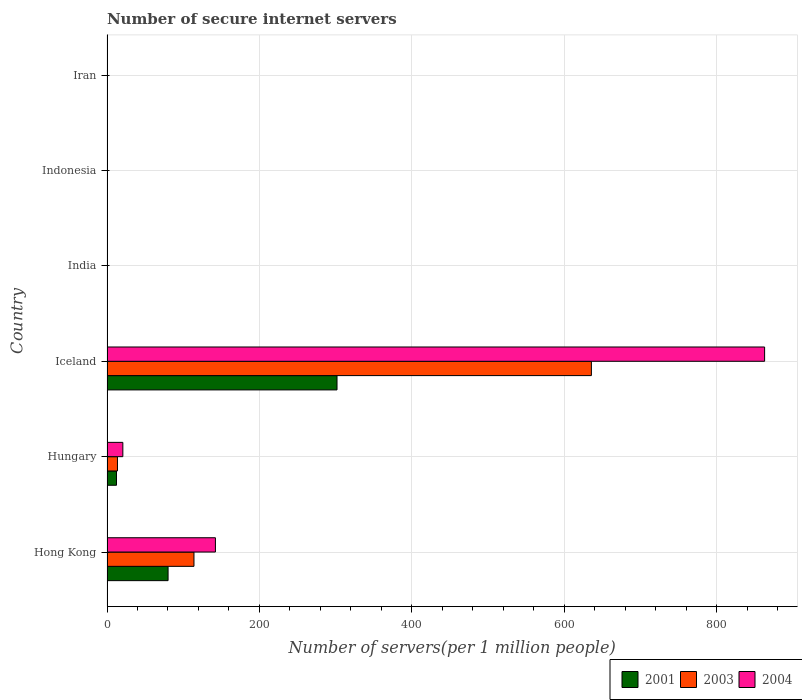Are the number of bars per tick equal to the number of legend labels?
Provide a short and direct response. Yes. How many bars are there on the 4th tick from the bottom?
Give a very brief answer. 3. What is the label of the 6th group of bars from the top?
Your response must be concise. Hong Kong. In how many cases, is the number of bars for a given country not equal to the number of legend labels?
Ensure brevity in your answer.  0. What is the number of secure internet servers in 2001 in Hungary?
Ensure brevity in your answer.  12.47. Across all countries, what is the maximum number of secure internet servers in 2001?
Your response must be concise. 301.79. Across all countries, what is the minimum number of secure internet servers in 2004?
Your answer should be compact. 0.19. In which country was the number of secure internet servers in 2003 minimum?
Your answer should be compact. Iran. What is the total number of secure internet servers in 2004 in the graph?
Your response must be concise. 1026.81. What is the difference between the number of secure internet servers in 2001 in Hungary and that in Iceland?
Your answer should be compact. -289.32. What is the difference between the number of secure internet servers in 2004 in Hong Kong and the number of secure internet servers in 2001 in Indonesia?
Your answer should be very brief. 141.98. What is the average number of secure internet servers in 2003 per country?
Your response must be concise. 127.32. What is the difference between the number of secure internet servers in 2003 and number of secure internet servers in 2001 in India?
Your answer should be very brief. 0.14. What is the ratio of the number of secure internet servers in 2004 in Hong Kong to that in India?
Make the answer very short. 346.84. Is the number of secure internet servers in 2001 in Hong Kong less than that in Hungary?
Make the answer very short. No. What is the difference between the highest and the second highest number of secure internet servers in 2003?
Ensure brevity in your answer.  521.43. What is the difference between the highest and the lowest number of secure internet servers in 2004?
Provide a short and direct response. 862.61. In how many countries, is the number of secure internet servers in 2003 greater than the average number of secure internet servers in 2003 taken over all countries?
Provide a short and direct response. 1. What does the 3rd bar from the top in Indonesia represents?
Make the answer very short. 2001. What does the 2nd bar from the bottom in Hungary represents?
Offer a very short reply. 2003. How many countries are there in the graph?
Your response must be concise. 6. Are the values on the major ticks of X-axis written in scientific E-notation?
Keep it short and to the point. No. Does the graph contain grids?
Keep it short and to the point. Yes. Where does the legend appear in the graph?
Your response must be concise. Bottom right. How many legend labels are there?
Give a very brief answer. 3. How are the legend labels stacked?
Make the answer very short. Horizontal. What is the title of the graph?
Your answer should be very brief. Number of secure internet servers. Does "1984" appear as one of the legend labels in the graph?
Your answer should be very brief. No. What is the label or title of the X-axis?
Give a very brief answer. Number of servers(per 1 million people). What is the Number of servers(per 1 million people) of 2001 in Hong Kong?
Your answer should be very brief. 80.13. What is the Number of servers(per 1 million people) of 2003 in Hong Kong?
Offer a terse response. 114.1. What is the Number of servers(per 1 million people) of 2004 in Hong Kong?
Offer a terse response. 142.26. What is the Number of servers(per 1 million people) of 2001 in Hungary?
Ensure brevity in your answer.  12.47. What is the Number of servers(per 1 million people) in 2003 in Hungary?
Ensure brevity in your answer.  13.72. What is the Number of servers(per 1 million people) of 2004 in Hungary?
Provide a succinct answer. 20.78. What is the Number of servers(per 1 million people) of 2001 in Iceland?
Your response must be concise. 301.79. What is the Number of servers(per 1 million people) in 2003 in Iceland?
Keep it short and to the point. 635.53. What is the Number of servers(per 1 million people) of 2004 in Iceland?
Your response must be concise. 862.8. What is the Number of servers(per 1 million people) of 2001 in India?
Keep it short and to the point. 0.11. What is the Number of servers(per 1 million people) in 2003 in India?
Your answer should be compact. 0.25. What is the Number of servers(per 1 million people) in 2004 in India?
Keep it short and to the point. 0.41. What is the Number of servers(per 1 million people) of 2001 in Indonesia?
Provide a short and direct response. 0.28. What is the Number of servers(per 1 million people) in 2003 in Indonesia?
Make the answer very short. 0.27. What is the Number of servers(per 1 million people) in 2004 in Indonesia?
Your response must be concise. 0.38. What is the Number of servers(per 1 million people) in 2001 in Iran?
Your response must be concise. 0.01. What is the Number of servers(per 1 million people) of 2003 in Iran?
Keep it short and to the point. 0.01. What is the Number of servers(per 1 million people) in 2004 in Iran?
Give a very brief answer. 0.19. Across all countries, what is the maximum Number of servers(per 1 million people) in 2001?
Keep it short and to the point. 301.79. Across all countries, what is the maximum Number of servers(per 1 million people) of 2003?
Your answer should be very brief. 635.53. Across all countries, what is the maximum Number of servers(per 1 million people) in 2004?
Provide a short and direct response. 862.8. Across all countries, what is the minimum Number of servers(per 1 million people) of 2001?
Keep it short and to the point. 0.01. Across all countries, what is the minimum Number of servers(per 1 million people) in 2003?
Make the answer very short. 0.01. Across all countries, what is the minimum Number of servers(per 1 million people) in 2004?
Give a very brief answer. 0.19. What is the total Number of servers(per 1 million people) in 2001 in the graph?
Offer a terse response. 394.79. What is the total Number of servers(per 1 million people) in 2003 in the graph?
Keep it short and to the point. 763.9. What is the total Number of servers(per 1 million people) of 2004 in the graph?
Your answer should be very brief. 1026.81. What is the difference between the Number of servers(per 1 million people) of 2001 in Hong Kong and that in Hungary?
Your answer should be very brief. 67.66. What is the difference between the Number of servers(per 1 million people) in 2003 in Hong Kong and that in Hungary?
Give a very brief answer. 100.38. What is the difference between the Number of servers(per 1 million people) of 2004 in Hong Kong and that in Hungary?
Keep it short and to the point. 121.48. What is the difference between the Number of servers(per 1 million people) in 2001 in Hong Kong and that in Iceland?
Give a very brief answer. -221.66. What is the difference between the Number of servers(per 1 million people) in 2003 in Hong Kong and that in Iceland?
Keep it short and to the point. -521.43. What is the difference between the Number of servers(per 1 million people) of 2004 in Hong Kong and that in Iceland?
Keep it short and to the point. -720.54. What is the difference between the Number of servers(per 1 million people) of 2001 in Hong Kong and that in India?
Make the answer very short. 80.01. What is the difference between the Number of servers(per 1 million people) of 2003 in Hong Kong and that in India?
Provide a short and direct response. 113.85. What is the difference between the Number of servers(per 1 million people) of 2004 in Hong Kong and that in India?
Provide a succinct answer. 141.85. What is the difference between the Number of servers(per 1 million people) in 2001 in Hong Kong and that in Indonesia?
Your answer should be compact. 79.85. What is the difference between the Number of servers(per 1 million people) in 2003 in Hong Kong and that in Indonesia?
Make the answer very short. 113.83. What is the difference between the Number of servers(per 1 million people) of 2004 in Hong Kong and that in Indonesia?
Your answer should be very brief. 141.88. What is the difference between the Number of servers(per 1 million people) of 2001 in Hong Kong and that in Iran?
Provide a short and direct response. 80.11. What is the difference between the Number of servers(per 1 million people) of 2003 in Hong Kong and that in Iran?
Provide a succinct answer. 114.09. What is the difference between the Number of servers(per 1 million people) of 2004 in Hong Kong and that in Iran?
Offer a terse response. 142.07. What is the difference between the Number of servers(per 1 million people) of 2001 in Hungary and that in Iceland?
Provide a short and direct response. -289.32. What is the difference between the Number of servers(per 1 million people) of 2003 in Hungary and that in Iceland?
Make the answer very short. -621.81. What is the difference between the Number of servers(per 1 million people) in 2004 in Hungary and that in Iceland?
Your answer should be very brief. -842.02. What is the difference between the Number of servers(per 1 million people) of 2001 in Hungary and that in India?
Provide a short and direct response. 12.35. What is the difference between the Number of servers(per 1 million people) in 2003 in Hungary and that in India?
Keep it short and to the point. 13.47. What is the difference between the Number of servers(per 1 million people) in 2004 in Hungary and that in India?
Give a very brief answer. 20.37. What is the difference between the Number of servers(per 1 million people) in 2001 in Hungary and that in Indonesia?
Your answer should be compact. 12.19. What is the difference between the Number of servers(per 1 million people) in 2003 in Hungary and that in Indonesia?
Offer a very short reply. 13.45. What is the difference between the Number of servers(per 1 million people) of 2004 in Hungary and that in Indonesia?
Offer a very short reply. 20.4. What is the difference between the Number of servers(per 1 million people) of 2001 in Hungary and that in Iran?
Make the answer very short. 12.45. What is the difference between the Number of servers(per 1 million people) in 2003 in Hungary and that in Iran?
Give a very brief answer. 13.71. What is the difference between the Number of servers(per 1 million people) in 2004 in Hungary and that in Iran?
Provide a succinct answer. 20.59. What is the difference between the Number of servers(per 1 million people) in 2001 in Iceland and that in India?
Provide a succinct answer. 301.67. What is the difference between the Number of servers(per 1 million people) in 2003 in Iceland and that in India?
Provide a succinct answer. 635.28. What is the difference between the Number of servers(per 1 million people) of 2004 in Iceland and that in India?
Ensure brevity in your answer.  862.38. What is the difference between the Number of servers(per 1 million people) of 2001 in Iceland and that in Indonesia?
Offer a very short reply. 301.51. What is the difference between the Number of servers(per 1 million people) in 2003 in Iceland and that in Indonesia?
Give a very brief answer. 635.26. What is the difference between the Number of servers(per 1 million people) in 2004 in Iceland and that in Indonesia?
Your response must be concise. 862.41. What is the difference between the Number of servers(per 1 million people) of 2001 in Iceland and that in Iran?
Your answer should be very brief. 301.77. What is the difference between the Number of servers(per 1 million people) in 2003 in Iceland and that in Iran?
Offer a terse response. 635.52. What is the difference between the Number of servers(per 1 million people) in 2004 in Iceland and that in Iran?
Your answer should be very brief. 862.61. What is the difference between the Number of servers(per 1 million people) in 2001 in India and that in Indonesia?
Ensure brevity in your answer.  -0.17. What is the difference between the Number of servers(per 1 million people) of 2003 in India and that in Indonesia?
Give a very brief answer. -0.02. What is the difference between the Number of servers(per 1 million people) in 2004 in India and that in Indonesia?
Offer a very short reply. 0.03. What is the difference between the Number of servers(per 1 million people) of 2001 in India and that in Iran?
Keep it short and to the point. 0.1. What is the difference between the Number of servers(per 1 million people) of 2003 in India and that in Iran?
Make the answer very short. 0.24. What is the difference between the Number of servers(per 1 million people) in 2004 in India and that in Iran?
Offer a very short reply. 0.22. What is the difference between the Number of servers(per 1 million people) of 2001 in Indonesia and that in Iran?
Keep it short and to the point. 0.26. What is the difference between the Number of servers(per 1 million people) of 2003 in Indonesia and that in Iran?
Your answer should be very brief. 0.26. What is the difference between the Number of servers(per 1 million people) in 2004 in Indonesia and that in Iran?
Ensure brevity in your answer.  0.19. What is the difference between the Number of servers(per 1 million people) in 2001 in Hong Kong and the Number of servers(per 1 million people) in 2003 in Hungary?
Offer a terse response. 66.41. What is the difference between the Number of servers(per 1 million people) in 2001 in Hong Kong and the Number of servers(per 1 million people) in 2004 in Hungary?
Give a very brief answer. 59.35. What is the difference between the Number of servers(per 1 million people) of 2003 in Hong Kong and the Number of servers(per 1 million people) of 2004 in Hungary?
Provide a short and direct response. 93.33. What is the difference between the Number of servers(per 1 million people) in 2001 in Hong Kong and the Number of servers(per 1 million people) in 2003 in Iceland?
Make the answer very short. -555.4. What is the difference between the Number of servers(per 1 million people) in 2001 in Hong Kong and the Number of servers(per 1 million people) in 2004 in Iceland?
Provide a short and direct response. -782.67. What is the difference between the Number of servers(per 1 million people) of 2003 in Hong Kong and the Number of servers(per 1 million people) of 2004 in Iceland?
Provide a succinct answer. -748.69. What is the difference between the Number of servers(per 1 million people) of 2001 in Hong Kong and the Number of servers(per 1 million people) of 2003 in India?
Offer a very short reply. 79.87. What is the difference between the Number of servers(per 1 million people) of 2001 in Hong Kong and the Number of servers(per 1 million people) of 2004 in India?
Provide a short and direct response. 79.72. What is the difference between the Number of servers(per 1 million people) of 2003 in Hong Kong and the Number of servers(per 1 million people) of 2004 in India?
Offer a terse response. 113.69. What is the difference between the Number of servers(per 1 million people) in 2001 in Hong Kong and the Number of servers(per 1 million people) in 2003 in Indonesia?
Offer a terse response. 79.86. What is the difference between the Number of servers(per 1 million people) in 2001 in Hong Kong and the Number of servers(per 1 million people) in 2004 in Indonesia?
Give a very brief answer. 79.75. What is the difference between the Number of servers(per 1 million people) of 2003 in Hong Kong and the Number of servers(per 1 million people) of 2004 in Indonesia?
Offer a terse response. 113.72. What is the difference between the Number of servers(per 1 million people) in 2001 in Hong Kong and the Number of servers(per 1 million people) in 2003 in Iran?
Your answer should be very brief. 80.11. What is the difference between the Number of servers(per 1 million people) of 2001 in Hong Kong and the Number of servers(per 1 million people) of 2004 in Iran?
Offer a terse response. 79.94. What is the difference between the Number of servers(per 1 million people) of 2003 in Hong Kong and the Number of servers(per 1 million people) of 2004 in Iran?
Offer a very short reply. 113.91. What is the difference between the Number of servers(per 1 million people) in 2001 in Hungary and the Number of servers(per 1 million people) in 2003 in Iceland?
Your response must be concise. -623.07. What is the difference between the Number of servers(per 1 million people) in 2001 in Hungary and the Number of servers(per 1 million people) in 2004 in Iceland?
Your answer should be very brief. -850.33. What is the difference between the Number of servers(per 1 million people) in 2003 in Hungary and the Number of servers(per 1 million people) in 2004 in Iceland?
Your answer should be very brief. -849.07. What is the difference between the Number of servers(per 1 million people) in 2001 in Hungary and the Number of servers(per 1 million people) in 2003 in India?
Your answer should be compact. 12.21. What is the difference between the Number of servers(per 1 million people) in 2001 in Hungary and the Number of servers(per 1 million people) in 2004 in India?
Ensure brevity in your answer.  12.06. What is the difference between the Number of servers(per 1 million people) of 2003 in Hungary and the Number of servers(per 1 million people) of 2004 in India?
Your answer should be compact. 13.31. What is the difference between the Number of servers(per 1 million people) of 2001 in Hungary and the Number of servers(per 1 million people) of 2003 in Indonesia?
Ensure brevity in your answer.  12.19. What is the difference between the Number of servers(per 1 million people) in 2001 in Hungary and the Number of servers(per 1 million people) in 2004 in Indonesia?
Offer a terse response. 12.09. What is the difference between the Number of servers(per 1 million people) in 2003 in Hungary and the Number of servers(per 1 million people) in 2004 in Indonesia?
Ensure brevity in your answer.  13.34. What is the difference between the Number of servers(per 1 million people) in 2001 in Hungary and the Number of servers(per 1 million people) in 2003 in Iran?
Your answer should be very brief. 12.45. What is the difference between the Number of servers(per 1 million people) of 2001 in Hungary and the Number of servers(per 1 million people) of 2004 in Iran?
Your answer should be very brief. 12.28. What is the difference between the Number of servers(per 1 million people) in 2003 in Hungary and the Number of servers(per 1 million people) in 2004 in Iran?
Ensure brevity in your answer.  13.53. What is the difference between the Number of servers(per 1 million people) of 2001 in Iceland and the Number of servers(per 1 million people) of 2003 in India?
Keep it short and to the point. 301.53. What is the difference between the Number of servers(per 1 million people) of 2001 in Iceland and the Number of servers(per 1 million people) of 2004 in India?
Your answer should be very brief. 301.38. What is the difference between the Number of servers(per 1 million people) of 2003 in Iceland and the Number of servers(per 1 million people) of 2004 in India?
Ensure brevity in your answer.  635.12. What is the difference between the Number of servers(per 1 million people) in 2001 in Iceland and the Number of servers(per 1 million people) in 2003 in Indonesia?
Provide a succinct answer. 301.52. What is the difference between the Number of servers(per 1 million people) of 2001 in Iceland and the Number of servers(per 1 million people) of 2004 in Indonesia?
Provide a succinct answer. 301.41. What is the difference between the Number of servers(per 1 million people) of 2003 in Iceland and the Number of servers(per 1 million people) of 2004 in Indonesia?
Give a very brief answer. 635.15. What is the difference between the Number of servers(per 1 million people) in 2001 in Iceland and the Number of servers(per 1 million people) in 2003 in Iran?
Make the answer very short. 301.77. What is the difference between the Number of servers(per 1 million people) of 2001 in Iceland and the Number of servers(per 1 million people) of 2004 in Iran?
Your response must be concise. 301.6. What is the difference between the Number of servers(per 1 million people) in 2003 in Iceland and the Number of servers(per 1 million people) in 2004 in Iran?
Offer a terse response. 635.35. What is the difference between the Number of servers(per 1 million people) of 2001 in India and the Number of servers(per 1 million people) of 2003 in Indonesia?
Offer a very short reply. -0.16. What is the difference between the Number of servers(per 1 million people) of 2001 in India and the Number of servers(per 1 million people) of 2004 in Indonesia?
Offer a terse response. -0.27. What is the difference between the Number of servers(per 1 million people) in 2003 in India and the Number of servers(per 1 million people) in 2004 in Indonesia?
Your response must be concise. -0.13. What is the difference between the Number of servers(per 1 million people) of 2001 in India and the Number of servers(per 1 million people) of 2003 in Iran?
Keep it short and to the point. 0.1. What is the difference between the Number of servers(per 1 million people) in 2001 in India and the Number of servers(per 1 million people) in 2004 in Iran?
Your answer should be compact. -0.07. What is the difference between the Number of servers(per 1 million people) in 2003 in India and the Number of servers(per 1 million people) in 2004 in Iran?
Your answer should be very brief. 0.07. What is the difference between the Number of servers(per 1 million people) of 2001 in Indonesia and the Number of servers(per 1 million people) of 2003 in Iran?
Keep it short and to the point. 0.27. What is the difference between the Number of servers(per 1 million people) in 2001 in Indonesia and the Number of servers(per 1 million people) in 2004 in Iran?
Provide a succinct answer. 0.09. What is the difference between the Number of servers(per 1 million people) in 2003 in Indonesia and the Number of servers(per 1 million people) in 2004 in Iran?
Offer a terse response. 0.08. What is the average Number of servers(per 1 million people) in 2001 per country?
Keep it short and to the point. 65.8. What is the average Number of servers(per 1 million people) of 2003 per country?
Provide a succinct answer. 127.32. What is the average Number of servers(per 1 million people) of 2004 per country?
Offer a very short reply. 171.13. What is the difference between the Number of servers(per 1 million people) of 2001 and Number of servers(per 1 million people) of 2003 in Hong Kong?
Provide a short and direct response. -33.97. What is the difference between the Number of servers(per 1 million people) of 2001 and Number of servers(per 1 million people) of 2004 in Hong Kong?
Offer a terse response. -62.13. What is the difference between the Number of servers(per 1 million people) in 2003 and Number of servers(per 1 million people) in 2004 in Hong Kong?
Make the answer very short. -28.15. What is the difference between the Number of servers(per 1 million people) of 2001 and Number of servers(per 1 million people) of 2003 in Hungary?
Keep it short and to the point. -1.26. What is the difference between the Number of servers(per 1 million people) in 2001 and Number of servers(per 1 million people) in 2004 in Hungary?
Give a very brief answer. -8.31. What is the difference between the Number of servers(per 1 million people) of 2003 and Number of servers(per 1 million people) of 2004 in Hungary?
Keep it short and to the point. -7.06. What is the difference between the Number of servers(per 1 million people) of 2001 and Number of servers(per 1 million people) of 2003 in Iceland?
Your answer should be very brief. -333.74. What is the difference between the Number of servers(per 1 million people) of 2001 and Number of servers(per 1 million people) of 2004 in Iceland?
Give a very brief answer. -561.01. What is the difference between the Number of servers(per 1 million people) in 2003 and Number of servers(per 1 million people) in 2004 in Iceland?
Provide a succinct answer. -227.26. What is the difference between the Number of servers(per 1 million people) in 2001 and Number of servers(per 1 million people) in 2003 in India?
Keep it short and to the point. -0.14. What is the difference between the Number of servers(per 1 million people) of 2001 and Number of servers(per 1 million people) of 2004 in India?
Provide a short and direct response. -0.3. What is the difference between the Number of servers(per 1 million people) of 2003 and Number of servers(per 1 million people) of 2004 in India?
Your response must be concise. -0.16. What is the difference between the Number of servers(per 1 million people) of 2001 and Number of servers(per 1 million people) of 2003 in Indonesia?
Provide a succinct answer. 0.01. What is the difference between the Number of servers(per 1 million people) of 2001 and Number of servers(per 1 million people) of 2004 in Indonesia?
Your answer should be very brief. -0.1. What is the difference between the Number of servers(per 1 million people) in 2003 and Number of servers(per 1 million people) in 2004 in Indonesia?
Provide a succinct answer. -0.11. What is the difference between the Number of servers(per 1 million people) of 2001 and Number of servers(per 1 million people) of 2003 in Iran?
Offer a very short reply. 0. What is the difference between the Number of servers(per 1 million people) of 2001 and Number of servers(per 1 million people) of 2004 in Iran?
Your response must be concise. -0.17. What is the difference between the Number of servers(per 1 million people) in 2003 and Number of servers(per 1 million people) in 2004 in Iran?
Your response must be concise. -0.17. What is the ratio of the Number of servers(per 1 million people) of 2001 in Hong Kong to that in Hungary?
Make the answer very short. 6.43. What is the ratio of the Number of servers(per 1 million people) in 2003 in Hong Kong to that in Hungary?
Ensure brevity in your answer.  8.32. What is the ratio of the Number of servers(per 1 million people) in 2004 in Hong Kong to that in Hungary?
Keep it short and to the point. 6.85. What is the ratio of the Number of servers(per 1 million people) in 2001 in Hong Kong to that in Iceland?
Make the answer very short. 0.27. What is the ratio of the Number of servers(per 1 million people) in 2003 in Hong Kong to that in Iceland?
Provide a short and direct response. 0.18. What is the ratio of the Number of servers(per 1 million people) of 2004 in Hong Kong to that in Iceland?
Ensure brevity in your answer.  0.16. What is the ratio of the Number of servers(per 1 million people) in 2001 in Hong Kong to that in India?
Your response must be concise. 704. What is the ratio of the Number of servers(per 1 million people) of 2003 in Hong Kong to that in India?
Ensure brevity in your answer.  450.06. What is the ratio of the Number of servers(per 1 million people) of 2004 in Hong Kong to that in India?
Provide a succinct answer. 346.84. What is the ratio of the Number of servers(per 1 million people) of 2001 in Hong Kong to that in Indonesia?
Your answer should be very brief. 286.39. What is the ratio of the Number of servers(per 1 million people) of 2003 in Hong Kong to that in Indonesia?
Your answer should be very brief. 418.96. What is the ratio of the Number of servers(per 1 million people) in 2004 in Hong Kong to that in Indonesia?
Your answer should be compact. 373.66. What is the ratio of the Number of servers(per 1 million people) in 2001 in Hong Kong to that in Iran?
Give a very brief answer. 5353.54. What is the ratio of the Number of servers(per 1 million people) in 2003 in Hong Kong to that in Iran?
Make the answer very short. 7818.53. What is the ratio of the Number of servers(per 1 million people) in 2004 in Hong Kong to that in Iran?
Provide a succinct answer. 758.58. What is the ratio of the Number of servers(per 1 million people) of 2001 in Hungary to that in Iceland?
Keep it short and to the point. 0.04. What is the ratio of the Number of servers(per 1 million people) in 2003 in Hungary to that in Iceland?
Give a very brief answer. 0.02. What is the ratio of the Number of servers(per 1 million people) in 2004 in Hungary to that in Iceland?
Provide a short and direct response. 0.02. What is the ratio of the Number of servers(per 1 million people) of 2001 in Hungary to that in India?
Give a very brief answer. 109.53. What is the ratio of the Number of servers(per 1 million people) in 2003 in Hungary to that in India?
Provide a short and direct response. 54.13. What is the ratio of the Number of servers(per 1 million people) of 2004 in Hungary to that in India?
Offer a terse response. 50.66. What is the ratio of the Number of servers(per 1 million people) of 2001 in Hungary to that in Indonesia?
Provide a succinct answer. 44.56. What is the ratio of the Number of servers(per 1 million people) in 2003 in Hungary to that in Indonesia?
Provide a succinct answer. 50.39. What is the ratio of the Number of servers(per 1 million people) in 2004 in Hungary to that in Indonesia?
Keep it short and to the point. 54.58. What is the ratio of the Number of servers(per 1 million people) of 2001 in Hungary to that in Iran?
Offer a terse response. 832.9. What is the ratio of the Number of servers(per 1 million people) in 2003 in Hungary to that in Iran?
Provide a succinct answer. 940.28. What is the ratio of the Number of servers(per 1 million people) in 2004 in Hungary to that in Iran?
Your answer should be very brief. 110.79. What is the ratio of the Number of servers(per 1 million people) in 2001 in Iceland to that in India?
Provide a succinct answer. 2651.5. What is the ratio of the Number of servers(per 1 million people) of 2003 in Iceland to that in India?
Offer a very short reply. 2506.78. What is the ratio of the Number of servers(per 1 million people) in 2004 in Iceland to that in India?
Make the answer very short. 2103.61. What is the ratio of the Number of servers(per 1 million people) of 2001 in Iceland to that in Indonesia?
Keep it short and to the point. 1078.63. What is the ratio of the Number of servers(per 1 million people) in 2003 in Iceland to that in Indonesia?
Your response must be concise. 2333.55. What is the ratio of the Number of servers(per 1 million people) in 2004 in Iceland to that in Indonesia?
Offer a very short reply. 2266.29. What is the ratio of the Number of servers(per 1 million people) of 2001 in Iceland to that in Iran?
Offer a terse response. 2.02e+04. What is the ratio of the Number of servers(per 1 million people) of 2003 in Iceland to that in Iran?
Offer a terse response. 4.35e+04. What is the ratio of the Number of servers(per 1 million people) of 2004 in Iceland to that in Iran?
Your answer should be compact. 4600.82. What is the ratio of the Number of servers(per 1 million people) of 2001 in India to that in Indonesia?
Make the answer very short. 0.41. What is the ratio of the Number of servers(per 1 million people) of 2003 in India to that in Indonesia?
Keep it short and to the point. 0.93. What is the ratio of the Number of servers(per 1 million people) in 2004 in India to that in Indonesia?
Your response must be concise. 1.08. What is the ratio of the Number of servers(per 1 million people) in 2001 in India to that in Iran?
Make the answer very short. 7.6. What is the ratio of the Number of servers(per 1 million people) of 2003 in India to that in Iran?
Offer a terse response. 17.37. What is the ratio of the Number of servers(per 1 million people) of 2004 in India to that in Iran?
Make the answer very short. 2.19. What is the ratio of the Number of servers(per 1 million people) of 2001 in Indonesia to that in Iran?
Your answer should be very brief. 18.69. What is the ratio of the Number of servers(per 1 million people) of 2003 in Indonesia to that in Iran?
Ensure brevity in your answer.  18.66. What is the ratio of the Number of servers(per 1 million people) of 2004 in Indonesia to that in Iran?
Your answer should be compact. 2.03. What is the difference between the highest and the second highest Number of servers(per 1 million people) in 2001?
Offer a very short reply. 221.66. What is the difference between the highest and the second highest Number of servers(per 1 million people) of 2003?
Ensure brevity in your answer.  521.43. What is the difference between the highest and the second highest Number of servers(per 1 million people) of 2004?
Provide a succinct answer. 720.54. What is the difference between the highest and the lowest Number of servers(per 1 million people) in 2001?
Provide a succinct answer. 301.77. What is the difference between the highest and the lowest Number of servers(per 1 million people) in 2003?
Keep it short and to the point. 635.52. What is the difference between the highest and the lowest Number of servers(per 1 million people) of 2004?
Offer a very short reply. 862.61. 